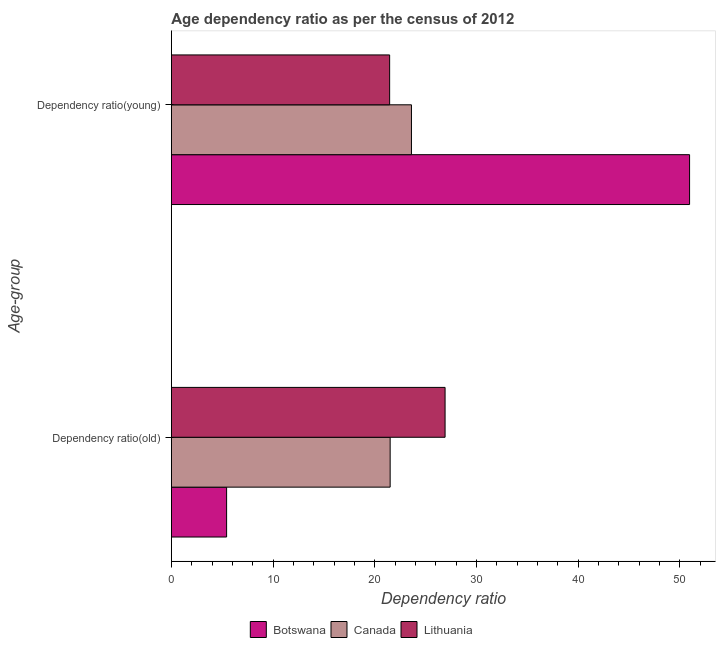How many different coloured bars are there?
Your response must be concise. 3. What is the label of the 2nd group of bars from the top?
Your answer should be compact. Dependency ratio(old). What is the age dependency ratio(young) in Canada?
Your response must be concise. 23.61. Across all countries, what is the maximum age dependency ratio(old)?
Your response must be concise. 26.92. Across all countries, what is the minimum age dependency ratio(old)?
Ensure brevity in your answer.  5.43. In which country was the age dependency ratio(young) maximum?
Give a very brief answer. Botswana. In which country was the age dependency ratio(old) minimum?
Your response must be concise. Botswana. What is the total age dependency ratio(young) in the graph?
Ensure brevity in your answer.  96.05. What is the difference between the age dependency ratio(old) in Lithuania and that in Botswana?
Make the answer very short. 21.49. What is the difference between the age dependency ratio(young) in Lithuania and the age dependency ratio(old) in Botswana?
Keep it short and to the point. 16.03. What is the average age dependency ratio(young) per country?
Give a very brief answer. 32.02. What is the difference between the age dependency ratio(old) and age dependency ratio(young) in Botswana?
Your answer should be compact. -45.54. What is the ratio of the age dependency ratio(young) in Canada to that in Botswana?
Offer a terse response. 0.46. Is the age dependency ratio(young) in Botswana less than that in Lithuania?
Your answer should be very brief. No. In how many countries, is the age dependency ratio(old) greater than the average age dependency ratio(old) taken over all countries?
Offer a very short reply. 2. Are all the bars in the graph horizontal?
Make the answer very short. Yes. How many countries are there in the graph?
Your answer should be compact. 3. What is the difference between two consecutive major ticks on the X-axis?
Provide a succinct answer. 10. Does the graph contain grids?
Provide a short and direct response. No. How are the legend labels stacked?
Your answer should be very brief. Horizontal. What is the title of the graph?
Your answer should be compact. Age dependency ratio as per the census of 2012. What is the label or title of the X-axis?
Your response must be concise. Dependency ratio. What is the label or title of the Y-axis?
Provide a short and direct response. Age-group. What is the Dependency ratio in Botswana in Dependency ratio(old)?
Your answer should be compact. 5.43. What is the Dependency ratio of Canada in Dependency ratio(old)?
Ensure brevity in your answer.  21.52. What is the Dependency ratio of Lithuania in Dependency ratio(old)?
Ensure brevity in your answer.  26.92. What is the Dependency ratio in Botswana in Dependency ratio(young)?
Your answer should be compact. 50.97. What is the Dependency ratio in Canada in Dependency ratio(young)?
Your answer should be compact. 23.61. What is the Dependency ratio in Lithuania in Dependency ratio(young)?
Ensure brevity in your answer.  21.47. Across all Age-group, what is the maximum Dependency ratio of Botswana?
Offer a very short reply. 50.97. Across all Age-group, what is the maximum Dependency ratio of Canada?
Your response must be concise. 23.61. Across all Age-group, what is the maximum Dependency ratio in Lithuania?
Make the answer very short. 26.92. Across all Age-group, what is the minimum Dependency ratio in Botswana?
Keep it short and to the point. 5.43. Across all Age-group, what is the minimum Dependency ratio in Canada?
Your answer should be very brief. 21.52. Across all Age-group, what is the minimum Dependency ratio in Lithuania?
Your answer should be compact. 21.47. What is the total Dependency ratio in Botswana in the graph?
Make the answer very short. 56.4. What is the total Dependency ratio of Canada in the graph?
Make the answer very short. 45.13. What is the total Dependency ratio of Lithuania in the graph?
Offer a very short reply. 48.39. What is the difference between the Dependency ratio of Botswana in Dependency ratio(old) and that in Dependency ratio(young)?
Give a very brief answer. -45.54. What is the difference between the Dependency ratio in Canada in Dependency ratio(old) and that in Dependency ratio(young)?
Your response must be concise. -2.09. What is the difference between the Dependency ratio in Lithuania in Dependency ratio(old) and that in Dependency ratio(young)?
Give a very brief answer. 5.45. What is the difference between the Dependency ratio in Botswana in Dependency ratio(old) and the Dependency ratio in Canada in Dependency ratio(young)?
Give a very brief answer. -18.18. What is the difference between the Dependency ratio in Botswana in Dependency ratio(old) and the Dependency ratio in Lithuania in Dependency ratio(young)?
Make the answer very short. -16.03. What is the difference between the Dependency ratio of Canada in Dependency ratio(old) and the Dependency ratio of Lithuania in Dependency ratio(young)?
Ensure brevity in your answer.  0.05. What is the average Dependency ratio of Botswana per Age-group?
Your answer should be very brief. 28.2. What is the average Dependency ratio in Canada per Age-group?
Your response must be concise. 22.57. What is the average Dependency ratio of Lithuania per Age-group?
Keep it short and to the point. 24.19. What is the difference between the Dependency ratio of Botswana and Dependency ratio of Canada in Dependency ratio(old)?
Offer a very short reply. -16.09. What is the difference between the Dependency ratio of Botswana and Dependency ratio of Lithuania in Dependency ratio(old)?
Provide a short and direct response. -21.49. What is the difference between the Dependency ratio of Canada and Dependency ratio of Lithuania in Dependency ratio(old)?
Your answer should be compact. -5.4. What is the difference between the Dependency ratio of Botswana and Dependency ratio of Canada in Dependency ratio(young)?
Give a very brief answer. 27.36. What is the difference between the Dependency ratio in Botswana and Dependency ratio in Lithuania in Dependency ratio(young)?
Ensure brevity in your answer.  29.5. What is the difference between the Dependency ratio in Canada and Dependency ratio in Lithuania in Dependency ratio(young)?
Keep it short and to the point. 2.15. What is the ratio of the Dependency ratio in Botswana in Dependency ratio(old) to that in Dependency ratio(young)?
Make the answer very short. 0.11. What is the ratio of the Dependency ratio of Canada in Dependency ratio(old) to that in Dependency ratio(young)?
Make the answer very short. 0.91. What is the ratio of the Dependency ratio in Lithuania in Dependency ratio(old) to that in Dependency ratio(young)?
Your response must be concise. 1.25. What is the difference between the highest and the second highest Dependency ratio of Botswana?
Offer a very short reply. 45.54. What is the difference between the highest and the second highest Dependency ratio in Canada?
Provide a succinct answer. 2.09. What is the difference between the highest and the second highest Dependency ratio in Lithuania?
Ensure brevity in your answer.  5.45. What is the difference between the highest and the lowest Dependency ratio of Botswana?
Keep it short and to the point. 45.54. What is the difference between the highest and the lowest Dependency ratio in Canada?
Ensure brevity in your answer.  2.09. What is the difference between the highest and the lowest Dependency ratio of Lithuania?
Your response must be concise. 5.45. 